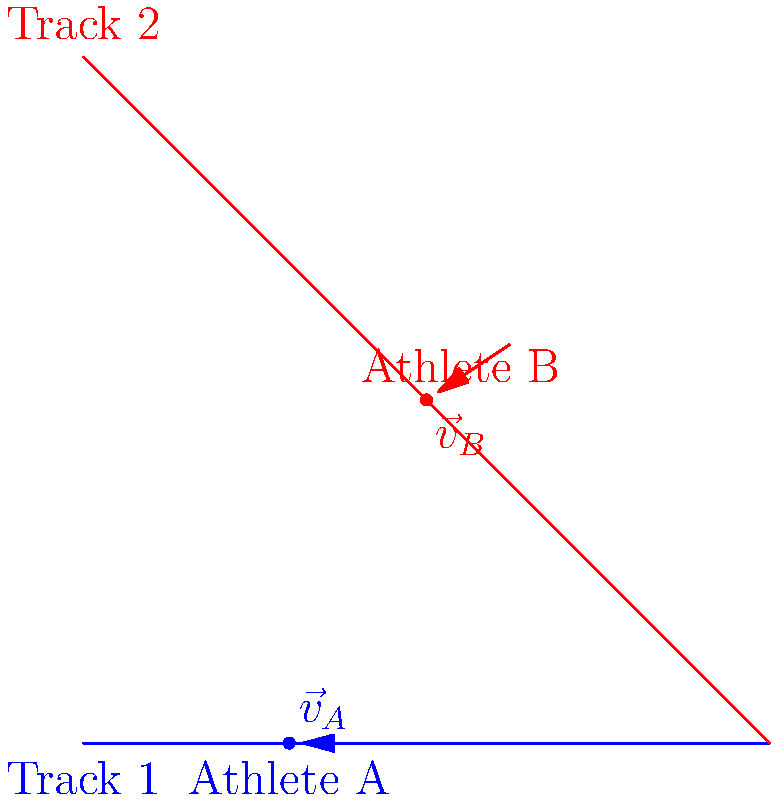As a professional athlete, you're analyzing the relative motion between two runners on intersecting tracks. Athlete A is running on Track 1 with a velocity of 8 m/s east, while Athlete B is running on Track 2 with a velocity of 6 m/s southeast (45° below the horizontal). What is the relative velocity vector of Athlete B with respect to Athlete A? To find the relative velocity vector of Athlete B with respect to Athlete A, we need to follow these steps:

1. Define the velocity vectors:
   Athlete A: $\vec{v}_A = 8\hat{i}$ m/s
   Athlete B: $\vec{v}_B = 6\cos(45°)\hat{i} + 6\sin(45°)\hat{j}$ m/s

2. Calculate the components of $\vec{v}_B$:
   $\vec{v}_B = 6\cos(45°)\hat{i} + 6\sin(45°)\hat{j}$
   $\vec{v}_B = 6 \cdot \frac{\sqrt{2}}{2}\hat{i} + 6 \cdot \frac{\sqrt{2}}{2}\hat{j}$
   $\vec{v}_B = 3\sqrt{2}\hat{i} + 3\sqrt{2}\hat{j}$ m/s

3. Calculate the relative velocity vector:
   $\vec{v}_{B/A} = \vec{v}_B - \vec{v}_A$
   $\vec{v}_{B/A} = (3\sqrt{2}\hat{i} + 3\sqrt{2}\hat{j}) - 8\hat{i}$
   $\vec{v}_{B/A} = (3\sqrt{2} - 8)\hat{i} + 3\sqrt{2}\hat{j}$ m/s

4. Simplify:
   $\vec{v}_{B/A} \approx -4.24\hat{i} + 4.24\hat{j}$ m/s

This vector represents the velocity of Athlete B as seen by Athlete A.
Answer: $\vec{v}_{B/A} \approx -4.24\hat{i} + 4.24\hat{j}$ m/s 